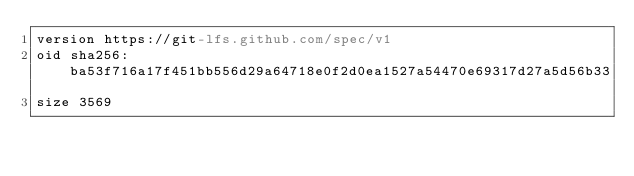Convert code to text. <code><loc_0><loc_0><loc_500><loc_500><_YAML_>version https://git-lfs.github.com/spec/v1
oid sha256:ba53f716a17f451bb556d29a64718e0f2d0ea1527a54470e69317d27a5d56b33
size 3569
</code> 